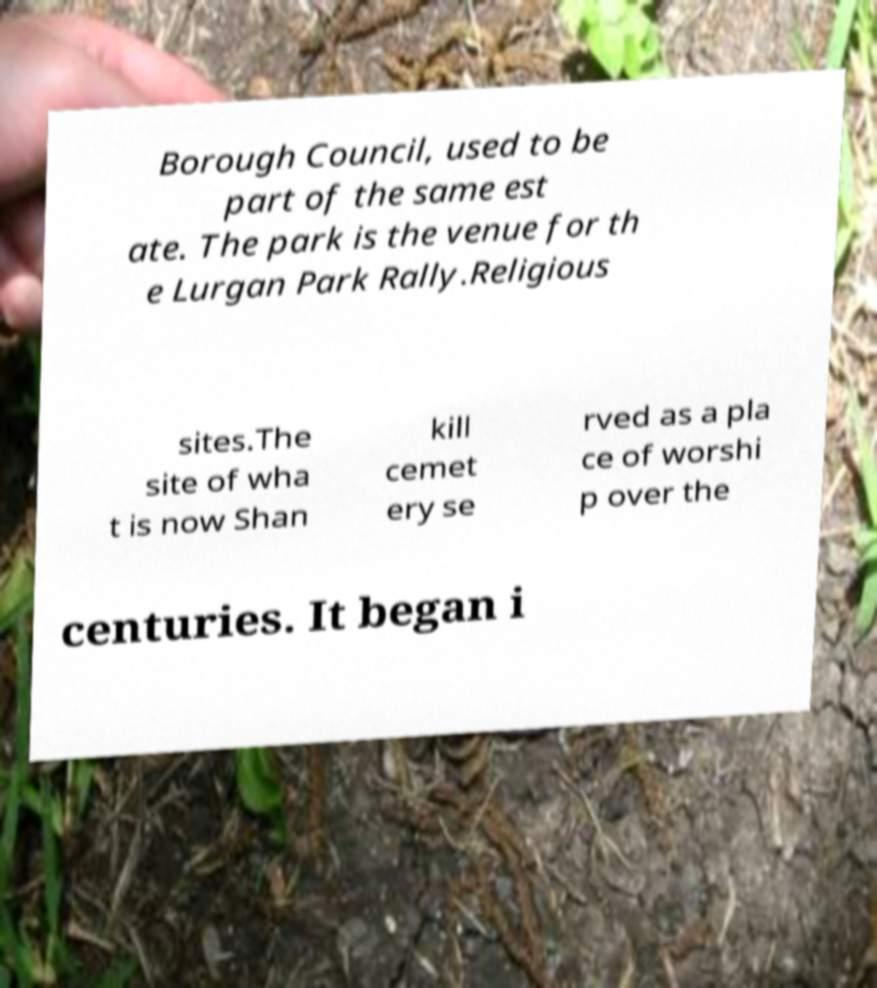Could you extract and type out the text from this image? Borough Council, used to be part of the same est ate. The park is the venue for th e Lurgan Park Rally.Religious sites.The site of wha t is now Shan kill cemet ery se rved as a pla ce of worshi p over the centuries. It began i 